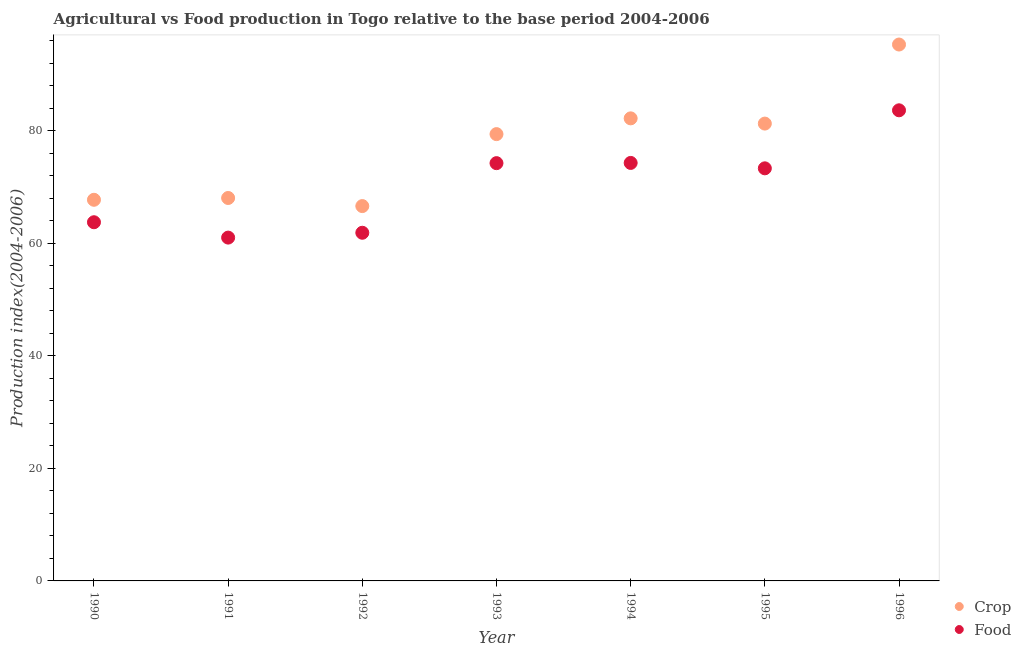How many different coloured dotlines are there?
Ensure brevity in your answer.  2. Is the number of dotlines equal to the number of legend labels?
Ensure brevity in your answer.  Yes. What is the food production index in 1994?
Give a very brief answer. 74.28. Across all years, what is the maximum crop production index?
Provide a short and direct response. 95.32. Across all years, what is the minimum crop production index?
Your response must be concise. 66.61. In which year was the crop production index maximum?
Keep it short and to the point. 1996. In which year was the food production index minimum?
Offer a very short reply. 1991. What is the total food production index in the graph?
Your answer should be compact. 492.09. What is the difference between the food production index in 1990 and that in 1991?
Ensure brevity in your answer.  2.73. What is the difference between the crop production index in 1990 and the food production index in 1992?
Ensure brevity in your answer.  5.86. What is the average crop production index per year?
Ensure brevity in your answer.  77.23. In the year 1995, what is the difference between the food production index and crop production index?
Ensure brevity in your answer.  -7.95. What is the ratio of the crop production index in 1995 to that in 1996?
Make the answer very short. 0.85. Is the food production index in 1991 less than that in 1994?
Your answer should be compact. Yes. Is the difference between the food production index in 1991 and 1994 greater than the difference between the crop production index in 1991 and 1994?
Provide a succinct answer. Yes. What is the difference between the highest and the second highest crop production index?
Offer a very short reply. 13.12. What is the difference between the highest and the lowest food production index?
Give a very brief answer. 22.62. Is the sum of the food production index in 1994 and 1995 greater than the maximum crop production index across all years?
Ensure brevity in your answer.  Yes. Is the crop production index strictly greater than the food production index over the years?
Offer a terse response. Yes. How many dotlines are there?
Your answer should be very brief. 2. Does the graph contain any zero values?
Offer a terse response. No. Does the graph contain grids?
Provide a short and direct response. No. How many legend labels are there?
Your response must be concise. 2. What is the title of the graph?
Provide a short and direct response. Agricultural vs Food production in Togo relative to the base period 2004-2006. Does "Secondary school" appear as one of the legend labels in the graph?
Make the answer very short. No. What is the label or title of the Y-axis?
Make the answer very short. Production index(2004-2006). What is the Production index(2004-2006) in Crop in 1990?
Your answer should be compact. 67.73. What is the Production index(2004-2006) of Food in 1990?
Your answer should be very brief. 63.74. What is the Production index(2004-2006) in Crop in 1991?
Ensure brevity in your answer.  68.05. What is the Production index(2004-2006) of Food in 1991?
Keep it short and to the point. 61.01. What is the Production index(2004-2006) in Crop in 1992?
Provide a short and direct response. 66.61. What is the Production index(2004-2006) in Food in 1992?
Your response must be concise. 61.87. What is the Production index(2004-2006) of Crop in 1993?
Make the answer very short. 79.4. What is the Production index(2004-2006) of Food in 1993?
Offer a very short reply. 74.24. What is the Production index(2004-2006) in Crop in 1994?
Provide a succinct answer. 82.2. What is the Production index(2004-2006) of Food in 1994?
Offer a very short reply. 74.28. What is the Production index(2004-2006) of Crop in 1995?
Ensure brevity in your answer.  81.27. What is the Production index(2004-2006) of Food in 1995?
Offer a very short reply. 73.32. What is the Production index(2004-2006) in Crop in 1996?
Your answer should be compact. 95.32. What is the Production index(2004-2006) in Food in 1996?
Offer a very short reply. 83.63. Across all years, what is the maximum Production index(2004-2006) of Crop?
Make the answer very short. 95.32. Across all years, what is the maximum Production index(2004-2006) of Food?
Make the answer very short. 83.63. Across all years, what is the minimum Production index(2004-2006) in Crop?
Provide a succinct answer. 66.61. Across all years, what is the minimum Production index(2004-2006) in Food?
Your answer should be very brief. 61.01. What is the total Production index(2004-2006) in Crop in the graph?
Give a very brief answer. 540.58. What is the total Production index(2004-2006) of Food in the graph?
Keep it short and to the point. 492.09. What is the difference between the Production index(2004-2006) in Crop in 1990 and that in 1991?
Offer a terse response. -0.32. What is the difference between the Production index(2004-2006) of Food in 1990 and that in 1991?
Offer a very short reply. 2.73. What is the difference between the Production index(2004-2006) in Crop in 1990 and that in 1992?
Provide a short and direct response. 1.12. What is the difference between the Production index(2004-2006) of Food in 1990 and that in 1992?
Your answer should be very brief. 1.87. What is the difference between the Production index(2004-2006) of Crop in 1990 and that in 1993?
Your answer should be compact. -11.67. What is the difference between the Production index(2004-2006) of Food in 1990 and that in 1993?
Provide a succinct answer. -10.5. What is the difference between the Production index(2004-2006) of Crop in 1990 and that in 1994?
Ensure brevity in your answer.  -14.47. What is the difference between the Production index(2004-2006) of Food in 1990 and that in 1994?
Your response must be concise. -10.54. What is the difference between the Production index(2004-2006) in Crop in 1990 and that in 1995?
Ensure brevity in your answer.  -13.54. What is the difference between the Production index(2004-2006) of Food in 1990 and that in 1995?
Ensure brevity in your answer.  -9.58. What is the difference between the Production index(2004-2006) in Crop in 1990 and that in 1996?
Offer a terse response. -27.59. What is the difference between the Production index(2004-2006) of Food in 1990 and that in 1996?
Your answer should be very brief. -19.89. What is the difference between the Production index(2004-2006) of Crop in 1991 and that in 1992?
Your response must be concise. 1.44. What is the difference between the Production index(2004-2006) of Food in 1991 and that in 1992?
Your answer should be very brief. -0.86. What is the difference between the Production index(2004-2006) of Crop in 1991 and that in 1993?
Offer a very short reply. -11.35. What is the difference between the Production index(2004-2006) in Food in 1991 and that in 1993?
Keep it short and to the point. -13.23. What is the difference between the Production index(2004-2006) of Crop in 1991 and that in 1994?
Your response must be concise. -14.15. What is the difference between the Production index(2004-2006) in Food in 1991 and that in 1994?
Your answer should be very brief. -13.27. What is the difference between the Production index(2004-2006) of Crop in 1991 and that in 1995?
Ensure brevity in your answer.  -13.22. What is the difference between the Production index(2004-2006) in Food in 1991 and that in 1995?
Your response must be concise. -12.31. What is the difference between the Production index(2004-2006) in Crop in 1991 and that in 1996?
Keep it short and to the point. -27.27. What is the difference between the Production index(2004-2006) in Food in 1991 and that in 1996?
Provide a succinct answer. -22.62. What is the difference between the Production index(2004-2006) of Crop in 1992 and that in 1993?
Offer a terse response. -12.79. What is the difference between the Production index(2004-2006) of Food in 1992 and that in 1993?
Your response must be concise. -12.37. What is the difference between the Production index(2004-2006) in Crop in 1992 and that in 1994?
Your answer should be compact. -15.59. What is the difference between the Production index(2004-2006) in Food in 1992 and that in 1994?
Your answer should be compact. -12.41. What is the difference between the Production index(2004-2006) in Crop in 1992 and that in 1995?
Give a very brief answer. -14.66. What is the difference between the Production index(2004-2006) in Food in 1992 and that in 1995?
Make the answer very short. -11.45. What is the difference between the Production index(2004-2006) in Crop in 1992 and that in 1996?
Give a very brief answer. -28.71. What is the difference between the Production index(2004-2006) of Food in 1992 and that in 1996?
Offer a very short reply. -21.76. What is the difference between the Production index(2004-2006) of Crop in 1993 and that in 1994?
Offer a terse response. -2.8. What is the difference between the Production index(2004-2006) in Food in 1993 and that in 1994?
Offer a very short reply. -0.04. What is the difference between the Production index(2004-2006) in Crop in 1993 and that in 1995?
Provide a short and direct response. -1.87. What is the difference between the Production index(2004-2006) of Crop in 1993 and that in 1996?
Provide a succinct answer. -15.92. What is the difference between the Production index(2004-2006) of Food in 1993 and that in 1996?
Ensure brevity in your answer.  -9.39. What is the difference between the Production index(2004-2006) of Crop in 1994 and that in 1995?
Offer a terse response. 0.93. What is the difference between the Production index(2004-2006) in Crop in 1994 and that in 1996?
Your response must be concise. -13.12. What is the difference between the Production index(2004-2006) in Food in 1994 and that in 1996?
Offer a terse response. -9.35. What is the difference between the Production index(2004-2006) in Crop in 1995 and that in 1996?
Keep it short and to the point. -14.05. What is the difference between the Production index(2004-2006) in Food in 1995 and that in 1996?
Your answer should be very brief. -10.31. What is the difference between the Production index(2004-2006) of Crop in 1990 and the Production index(2004-2006) of Food in 1991?
Offer a terse response. 6.72. What is the difference between the Production index(2004-2006) of Crop in 1990 and the Production index(2004-2006) of Food in 1992?
Offer a terse response. 5.86. What is the difference between the Production index(2004-2006) of Crop in 1990 and the Production index(2004-2006) of Food in 1993?
Your response must be concise. -6.51. What is the difference between the Production index(2004-2006) of Crop in 1990 and the Production index(2004-2006) of Food in 1994?
Your answer should be very brief. -6.55. What is the difference between the Production index(2004-2006) of Crop in 1990 and the Production index(2004-2006) of Food in 1995?
Offer a terse response. -5.59. What is the difference between the Production index(2004-2006) of Crop in 1990 and the Production index(2004-2006) of Food in 1996?
Provide a short and direct response. -15.9. What is the difference between the Production index(2004-2006) of Crop in 1991 and the Production index(2004-2006) of Food in 1992?
Offer a very short reply. 6.18. What is the difference between the Production index(2004-2006) in Crop in 1991 and the Production index(2004-2006) in Food in 1993?
Provide a short and direct response. -6.19. What is the difference between the Production index(2004-2006) of Crop in 1991 and the Production index(2004-2006) of Food in 1994?
Ensure brevity in your answer.  -6.23. What is the difference between the Production index(2004-2006) of Crop in 1991 and the Production index(2004-2006) of Food in 1995?
Provide a succinct answer. -5.27. What is the difference between the Production index(2004-2006) in Crop in 1991 and the Production index(2004-2006) in Food in 1996?
Your answer should be compact. -15.58. What is the difference between the Production index(2004-2006) in Crop in 1992 and the Production index(2004-2006) in Food in 1993?
Make the answer very short. -7.63. What is the difference between the Production index(2004-2006) in Crop in 1992 and the Production index(2004-2006) in Food in 1994?
Make the answer very short. -7.67. What is the difference between the Production index(2004-2006) of Crop in 1992 and the Production index(2004-2006) of Food in 1995?
Ensure brevity in your answer.  -6.71. What is the difference between the Production index(2004-2006) in Crop in 1992 and the Production index(2004-2006) in Food in 1996?
Give a very brief answer. -17.02. What is the difference between the Production index(2004-2006) of Crop in 1993 and the Production index(2004-2006) of Food in 1994?
Provide a short and direct response. 5.12. What is the difference between the Production index(2004-2006) of Crop in 1993 and the Production index(2004-2006) of Food in 1995?
Keep it short and to the point. 6.08. What is the difference between the Production index(2004-2006) of Crop in 1993 and the Production index(2004-2006) of Food in 1996?
Ensure brevity in your answer.  -4.23. What is the difference between the Production index(2004-2006) of Crop in 1994 and the Production index(2004-2006) of Food in 1995?
Provide a short and direct response. 8.88. What is the difference between the Production index(2004-2006) of Crop in 1994 and the Production index(2004-2006) of Food in 1996?
Ensure brevity in your answer.  -1.43. What is the difference between the Production index(2004-2006) of Crop in 1995 and the Production index(2004-2006) of Food in 1996?
Your response must be concise. -2.36. What is the average Production index(2004-2006) in Crop per year?
Offer a terse response. 77.23. What is the average Production index(2004-2006) of Food per year?
Your answer should be very brief. 70.3. In the year 1990, what is the difference between the Production index(2004-2006) in Crop and Production index(2004-2006) in Food?
Provide a succinct answer. 3.99. In the year 1991, what is the difference between the Production index(2004-2006) in Crop and Production index(2004-2006) in Food?
Keep it short and to the point. 7.04. In the year 1992, what is the difference between the Production index(2004-2006) in Crop and Production index(2004-2006) in Food?
Give a very brief answer. 4.74. In the year 1993, what is the difference between the Production index(2004-2006) of Crop and Production index(2004-2006) of Food?
Make the answer very short. 5.16. In the year 1994, what is the difference between the Production index(2004-2006) of Crop and Production index(2004-2006) of Food?
Provide a short and direct response. 7.92. In the year 1995, what is the difference between the Production index(2004-2006) in Crop and Production index(2004-2006) in Food?
Keep it short and to the point. 7.95. In the year 1996, what is the difference between the Production index(2004-2006) of Crop and Production index(2004-2006) of Food?
Ensure brevity in your answer.  11.69. What is the ratio of the Production index(2004-2006) in Crop in 1990 to that in 1991?
Make the answer very short. 1. What is the ratio of the Production index(2004-2006) of Food in 1990 to that in 1991?
Offer a terse response. 1.04. What is the ratio of the Production index(2004-2006) in Crop in 1990 to that in 1992?
Provide a succinct answer. 1.02. What is the ratio of the Production index(2004-2006) in Food in 1990 to that in 1992?
Offer a very short reply. 1.03. What is the ratio of the Production index(2004-2006) of Crop in 1990 to that in 1993?
Your answer should be very brief. 0.85. What is the ratio of the Production index(2004-2006) of Food in 1990 to that in 1993?
Offer a very short reply. 0.86. What is the ratio of the Production index(2004-2006) of Crop in 1990 to that in 1994?
Keep it short and to the point. 0.82. What is the ratio of the Production index(2004-2006) in Food in 1990 to that in 1994?
Offer a terse response. 0.86. What is the ratio of the Production index(2004-2006) in Crop in 1990 to that in 1995?
Provide a succinct answer. 0.83. What is the ratio of the Production index(2004-2006) in Food in 1990 to that in 1995?
Your answer should be very brief. 0.87. What is the ratio of the Production index(2004-2006) of Crop in 1990 to that in 1996?
Your answer should be very brief. 0.71. What is the ratio of the Production index(2004-2006) of Food in 1990 to that in 1996?
Your answer should be very brief. 0.76. What is the ratio of the Production index(2004-2006) of Crop in 1991 to that in 1992?
Provide a succinct answer. 1.02. What is the ratio of the Production index(2004-2006) of Food in 1991 to that in 1992?
Make the answer very short. 0.99. What is the ratio of the Production index(2004-2006) of Crop in 1991 to that in 1993?
Your response must be concise. 0.86. What is the ratio of the Production index(2004-2006) in Food in 1991 to that in 1993?
Give a very brief answer. 0.82. What is the ratio of the Production index(2004-2006) of Crop in 1991 to that in 1994?
Provide a short and direct response. 0.83. What is the ratio of the Production index(2004-2006) of Food in 1991 to that in 1994?
Offer a terse response. 0.82. What is the ratio of the Production index(2004-2006) of Crop in 1991 to that in 1995?
Your response must be concise. 0.84. What is the ratio of the Production index(2004-2006) in Food in 1991 to that in 1995?
Your answer should be very brief. 0.83. What is the ratio of the Production index(2004-2006) in Crop in 1991 to that in 1996?
Provide a short and direct response. 0.71. What is the ratio of the Production index(2004-2006) in Food in 1991 to that in 1996?
Give a very brief answer. 0.73. What is the ratio of the Production index(2004-2006) in Crop in 1992 to that in 1993?
Make the answer very short. 0.84. What is the ratio of the Production index(2004-2006) in Food in 1992 to that in 1993?
Provide a succinct answer. 0.83. What is the ratio of the Production index(2004-2006) in Crop in 1992 to that in 1994?
Provide a short and direct response. 0.81. What is the ratio of the Production index(2004-2006) of Food in 1992 to that in 1994?
Your answer should be compact. 0.83. What is the ratio of the Production index(2004-2006) of Crop in 1992 to that in 1995?
Make the answer very short. 0.82. What is the ratio of the Production index(2004-2006) of Food in 1992 to that in 1995?
Your answer should be compact. 0.84. What is the ratio of the Production index(2004-2006) in Crop in 1992 to that in 1996?
Your answer should be very brief. 0.7. What is the ratio of the Production index(2004-2006) in Food in 1992 to that in 1996?
Give a very brief answer. 0.74. What is the ratio of the Production index(2004-2006) in Crop in 1993 to that in 1994?
Give a very brief answer. 0.97. What is the ratio of the Production index(2004-2006) in Crop in 1993 to that in 1995?
Ensure brevity in your answer.  0.98. What is the ratio of the Production index(2004-2006) of Food in 1993 to that in 1995?
Offer a terse response. 1.01. What is the ratio of the Production index(2004-2006) of Crop in 1993 to that in 1996?
Provide a succinct answer. 0.83. What is the ratio of the Production index(2004-2006) in Food in 1993 to that in 1996?
Your answer should be compact. 0.89. What is the ratio of the Production index(2004-2006) in Crop in 1994 to that in 1995?
Make the answer very short. 1.01. What is the ratio of the Production index(2004-2006) of Food in 1994 to that in 1995?
Your answer should be compact. 1.01. What is the ratio of the Production index(2004-2006) in Crop in 1994 to that in 1996?
Make the answer very short. 0.86. What is the ratio of the Production index(2004-2006) of Food in 1994 to that in 1996?
Provide a short and direct response. 0.89. What is the ratio of the Production index(2004-2006) in Crop in 1995 to that in 1996?
Your response must be concise. 0.85. What is the ratio of the Production index(2004-2006) of Food in 1995 to that in 1996?
Your answer should be compact. 0.88. What is the difference between the highest and the second highest Production index(2004-2006) of Crop?
Offer a terse response. 13.12. What is the difference between the highest and the second highest Production index(2004-2006) in Food?
Your answer should be very brief. 9.35. What is the difference between the highest and the lowest Production index(2004-2006) in Crop?
Keep it short and to the point. 28.71. What is the difference between the highest and the lowest Production index(2004-2006) in Food?
Offer a terse response. 22.62. 